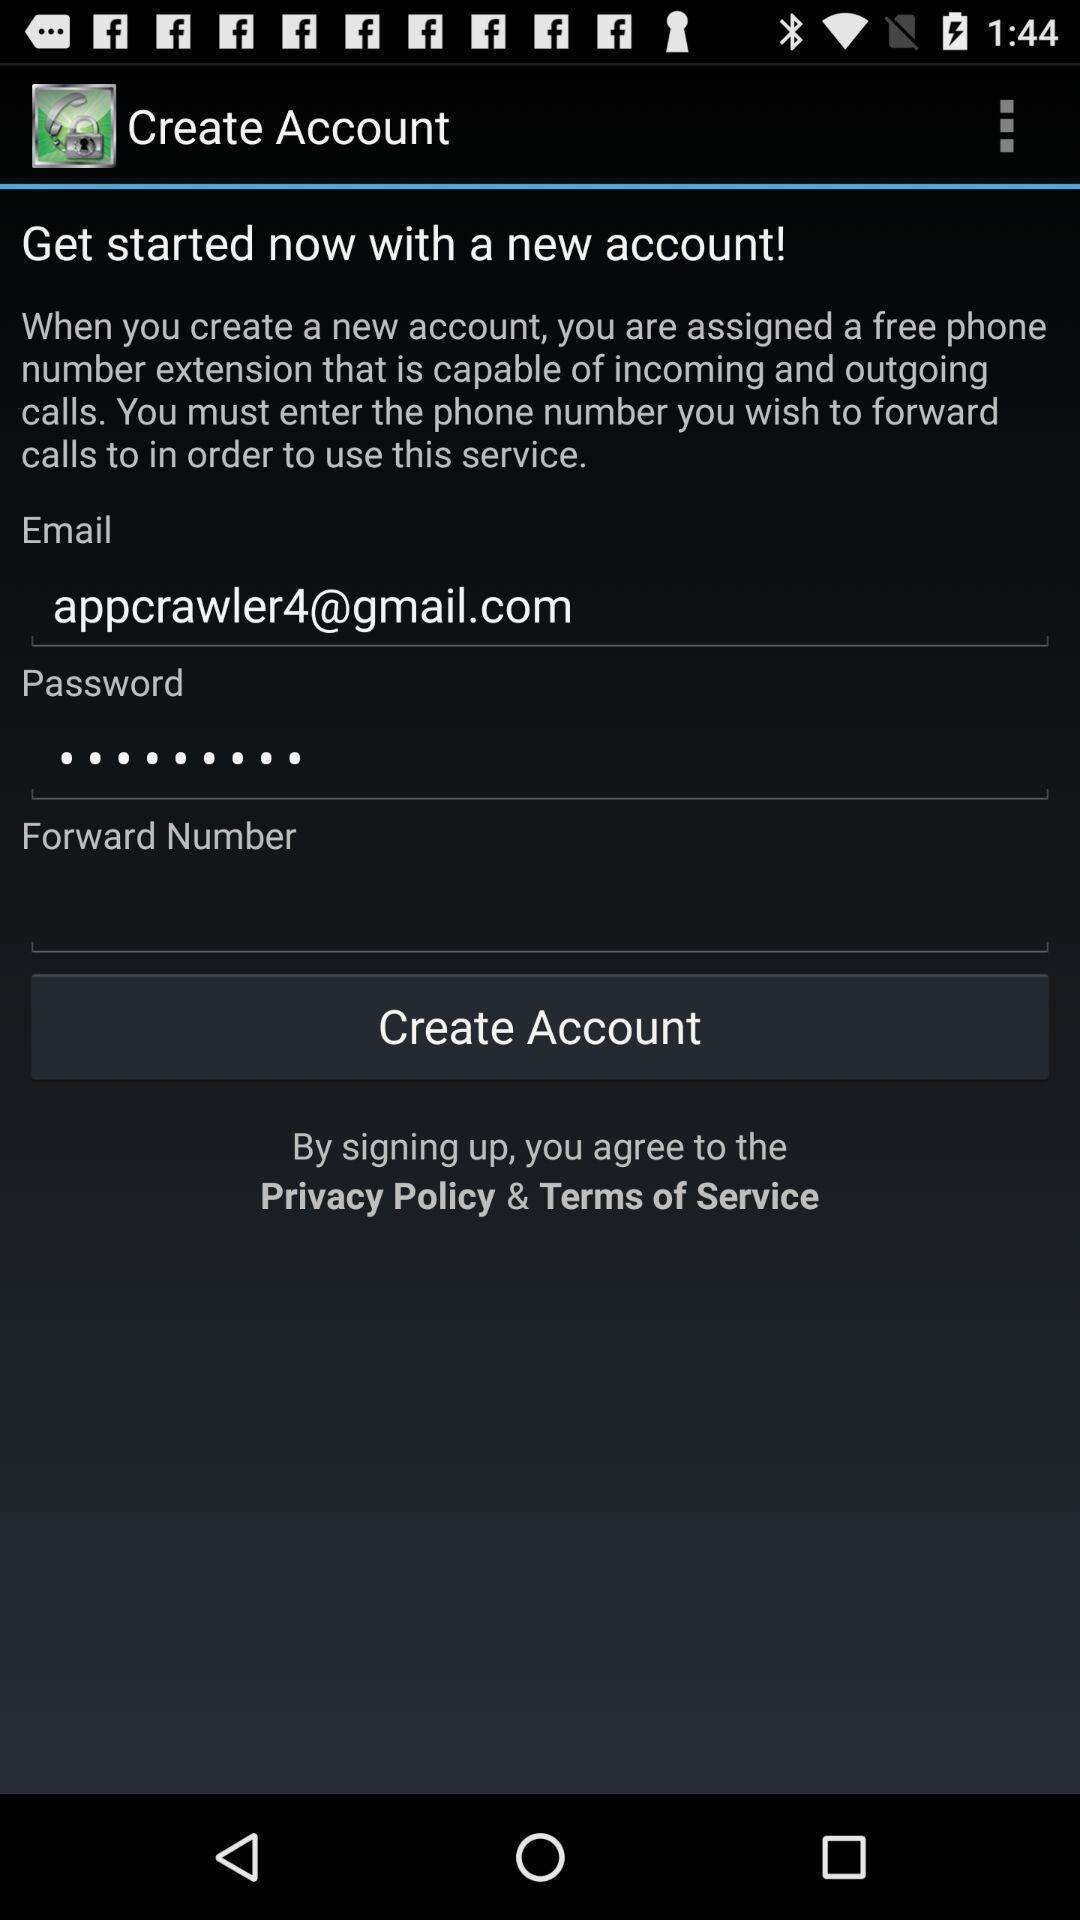Explain what's happening in this screen capture. Sign up page displayed. 